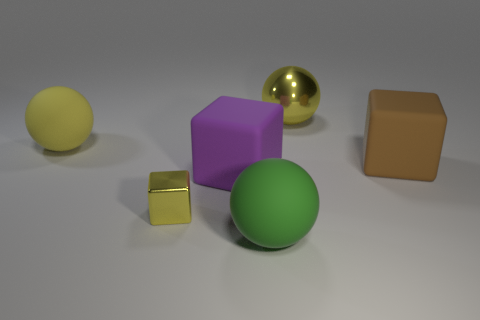Subtract all yellow metal spheres. How many spheres are left? 2 Subtract all purple cubes. How many yellow spheres are left? 2 Subtract 1 balls. How many balls are left? 2 Add 1 big red cylinders. How many objects exist? 7 Subtract all green spheres. How many spheres are left? 2 Subtract all big green objects. Subtract all tiny metallic blocks. How many objects are left? 4 Add 4 big matte objects. How many big matte objects are left? 8 Add 6 small shiny cubes. How many small shiny cubes exist? 7 Subtract 0 yellow cylinders. How many objects are left? 6 Subtract all red cubes. Subtract all green spheres. How many cubes are left? 3 